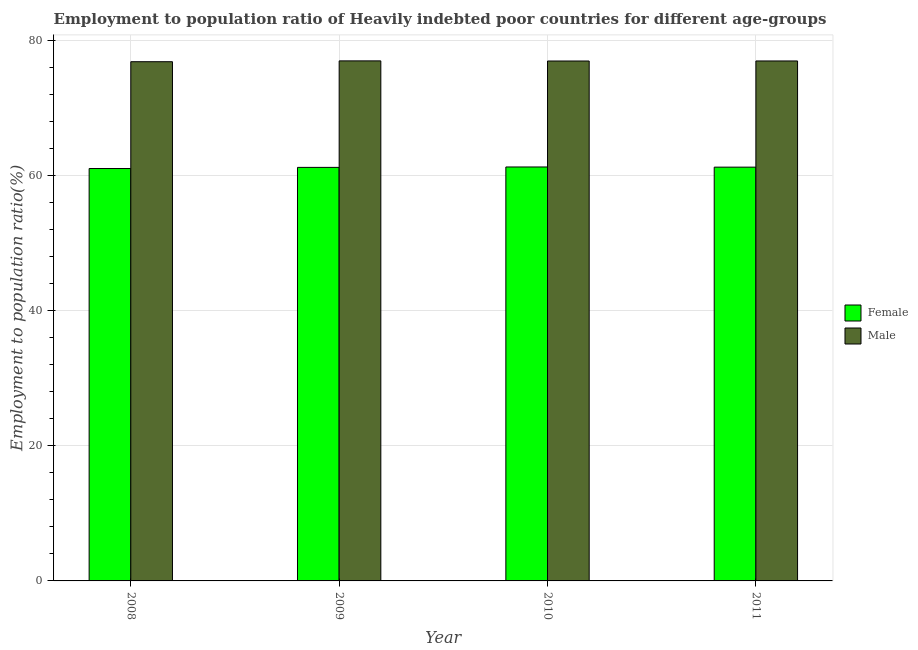How many different coloured bars are there?
Keep it short and to the point. 2. How many groups of bars are there?
Give a very brief answer. 4. How many bars are there on the 2nd tick from the left?
Provide a succinct answer. 2. What is the label of the 4th group of bars from the left?
Make the answer very short. 2011. In how many cases, is the number of bars for a given year not equal to the number of legend labels?
Keep it short and to the point. 0. What is the employment to population ratio(female) in 2008?
Give a very brief answer. 61.06. Across all years, what is the maximum employment to population ratio(male)?
Offer a very short reply. 77. Across all years, what is the minimum employment to population ratio(male)?
Ensure brevity in your answer.  76.87. In which year was the employment to population ratio(male) maximum?
Offer a terse response. 2009. In which year was the employment to population ratio(male) minimum?
Ensure brevity in your answer.  2008. What is the total employment to population ratio(female) in the graph?
Give a very brief answer. 244.84. What is the difference between the employment to population ratio(female) in 2008 and that in 2010?
Ensure brevity in your answer.  -0.23. What is the difference between the employment to population ratio(female) in 2011 and the employment to population ratio(male) in 2010?
Your answer should be very brief. -0.03. What is the average employment to population ratio(male) per year?
Provide a short and direct response. 76.96. In the year 2009, what is the difference between the employment to population ratio(male) and employment to population ratio(female)?
Give a very brief answer. 0. What is the ratio of the employment to population ratio(female) in 2010 to that in 2011?
Make the answer very short. 1. Is the employment to population ratio(male) in 2010 less than that in 2011?
Keep it short and to the point. Yes. What is the difference between the highest and the second highest employment to population ratio(male)?
Keep it short and to the point. 0.01. What is the difference between the highest and the lowest employment to population ratio(female)?
Your answer should be compact. 0.23. In how many years, is the employment to population ratio(female) greater than the average employment to population ratio(female) taken over all years?
Your answer should be very brief. 3. Is the sum of the employment to population ratio(female) in 2009 and 2011 greater than the maximum employment to population ratio(male) across all years?
Ensure brevity in your answer.  Yes. What does the 1st bar from the left in 2011 represents?
Keep it short and to the point. Female. What does the 2nd bar from the right in 2009 represents?
Make the answer very short. Female. How many bars are there?
Offer a terse response. 8. What is the difference between two consecutive major ticks on the Y-axis?
Offer a terse response. 20. Does the graph contain any zero values?
Make the answer very short. No. Does the graph contain grids?
Your answer should be compact. Yes. How many legend labels are there?
Provide a succinct answer. 2. How are the legend labels stacked?
Keep it short and to the point. Vertical. What is the title of the graph?
Your answer should be compact. Employment to population ratio of Heavily indebted poor countries for different age-groups. What is the label or title of the Y-axis?
Make the answer very short. Employment to population ratio(%). What is the Employment to population ratio(%) in Female in 2008?
Make the answer very short. 61.06. What is the Employment to population ratio(%) of Male in 2008?
Your answer should be compact. 76.87. What is the Employment to population ratio(%) in Female in 2009?
Give a very brief answer. 61.23. What is the Employment to population ratio(%) in Male in 2009?
Make the answer very short. 77. What is the Employment to population ratio(%) in Female in 2010?
Your response must be concise. 61.29. What is the Employment to population ratio(%) of Male in 2010?
Offer a terse response. 76.98. What is the Employment to population ratio(%) in Female in 2011?
Your answer should be compact. 61.26. What is the Employment to population ratio(%) of Male in 2011?
Keep it short and to the point. 76.99. Across all years, what is the maximum Employment to population ratio(%) of Female?
Your response must be concise. 61.29. Across all years, what is the maximum Employment to population ratio(%) of Male?
Make the answer very short. 77. Across all years, what is the minimum Employment to population ratio(%) in Female?
Your answer should be compact. 61.06. Across all years, what is the minimum Employment to population ratio(%) of Male?
Provide a short and direct response. 76.87. What is the total Employment to population ratio(%) of Female in the graph?
Ensure brevity in your answer.  244.84. What is the total Employment to population ratio(%) of Male in the graph?
Offer a very short reply. 307.84. What is the difference between the Employment to population ratio(%) in Female in 2008 and that in 2009?
Offer a very short reply. -0.17. What is the difference between the Employment to population ratio(%) in Male in 2008 and that in 2009?
Provide a short and direct response. -0.12. What is the difference between the Employment to population ratio(%) in Female in 2008 and that in 2010?
Provide a short and direct response. -0.23. What is the difference between the Employment to population ratio(%) in Male in 2008 and that in 2010?
Keep it short and to the point. -0.1. What is the difference between the Employment to population ratio(%) in Female in 2008 and that in 2011?
Provide a short and direct response. -0.2. What is the difference between the Employment to population ratio(%) of Male in 2008 and that in 2011?
Make the answer very short. -0.11. What is the difference between the Employment to population ratio(%) of Female in 2009 and that in 2010?
Provide a short and direct response. -0.06. What is the difference between the Employment to population ratio(%) in Male in 2009 and that in 2010?
Provide a short and direct response. 0.02. What is the difference between the Employment to population ratio(%) of Female in 2009 and that in 2011?
Give a very brief answer. -0.04. What is the difference between the Employment to population ratio(%) in Male in 2009 and that in 2011?
Offer a very short reply. 0.01. What is the difference between the Employment to population ratio(%) in Female in 2010 and that in 2011?
Offer a terse response. 0.03. What is the difference between the Employment to population ratio(%) of Male in 2010 and that in 2011?
Your response must be concise. -0.01. What is the difference between the Employment to population ratio(%) of Female in 2008 and the Employment to population ratio(%) of Male in 2009?
Your answer should be compact. -15.94. What is the difference between the Employment to population ratio(%) of Female in 2008 and the Employment to population ratio(%) of Male in 2010?
Offer a terse response. -15.92. What is the difference between the Employment to population ratio(%) in Female in 2008 and the Employment to population ratio(%) in Male in 2011?
Provide a succinct answer. -15.93. What is the difference between the Employment to population ratio(%) in Female in 2009 and the Employment to population ratio(%) in Male in 2010?
Give a very brief answer. -15.75. What is the difference between the Employment to population ratio(%) of Female in 2009 and the Employment to population ratio(%) of Male in 2011?
Your answer should be very brief. -15.76. What is the difference between the Employment to population ratio(%) in Female in 2010 and the Employment to population ratio(%) in Male in 2011?
Keep it short and to the point. -15.7. What is the average Employment to population ratio(%) in Female per year?
Provide a short and direct response. 61.21. What is the average Employment to population ratio(%) in Male per year?
Provide a succinct answer. 76.96. In the year 2008, what is the difference between the Employment to population ratio(%) in Female and Employment to population ratio(%) in Male?
Make the answer very short. -15.81. In the year 2009, what is the difference between the Employment to population ratio(%) in Female and Employment to population ratio(%) in Male?
Give a very brief answer. -15.77. In the year 2010, what is the difference between the Employment to population ratio(%) of Female and Employment to population ratio(%) of Male?
Make the answer very short. -15.69. In the year 2011, what is the difference between the Employment to population ratio(%) of Female and Employment to population ratio(%) of Male?
Your answer should be compact. -15.72. What is the ratio of the Employment to population ratio(%) of Female in 2008 to that in 2009?
Your answer should be very brief. 1. What is the ratio of the Employment to population ratio(%) in Female in 2008 to that in 2010?
Offer a terse response. 1. What is the ratio of the Employment to population ratio(%) in Male in 2008 to that in 2010?
Give a very brief answer. 1. What is the ratio of the Employment to population ratio(%) of Male in 2009 to that in 2011?
Provide a short and direct response. 1. What is the difference between the highest and the second highest Employment to population ratio(%) of Female?
Your answer should be compact. 0.03. What is the difference between the highest and the second highest Employment to population ratio(%) of Male?
Give a very brief answer. 0.01. What is the difference between the highest and the lowest Employment to population ratio(%) of Female?
Ensure brevity in your answer.  0.23. What is the difference between the highest and the lowest Employment to population ratio(%) in Male?
Keep it short and to the point. 0.12. 